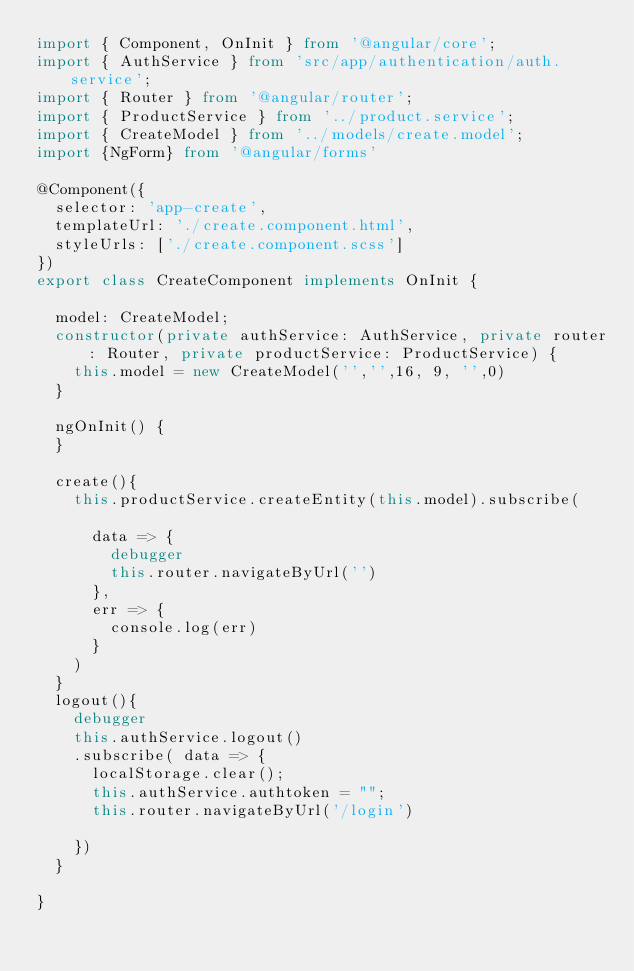<code> <loc_0><loc_0><loc_500><loc_500><_TypeScript_>import { Component, OnInit } from '@angular/core';
import { AuthService } from 'src/app/authentication/auth.service';
import { Router } from '@angular/router';
import { ProductService } from '../product.service';
import { CreateModel } from '../models/create.model';
import {NgForm} from '@angular/forms'

@Component({
  selector: 'app-create',
  templateUrl: './create.component.html',
  styleUrls: ['./create.component.scss']
})
export class CreateComponent implements OnInit {

  model: CreateModel;
  constructor(private authService: AuthService, private router: Router, private productService: ProductService) { 
    this.model = new CreateModel('','',16, 9, '',0)
  }

  ngOnInit() {
  }

  create(){
    this.productService.createEntity(this.model).subscribe(
      
      data => {
        debugger
        this.router.navigateByUrl('')
      },
      err => {
        console.log(err)
      }
    )
  }
  logout(){
    debugger
    this.authService.logout()
    .subscribe( data => {
      localStorage.clear();
      this.authService.authtoken = "";
      this.router.navigateByUrl('/login')

    })
  }

}
</code> 